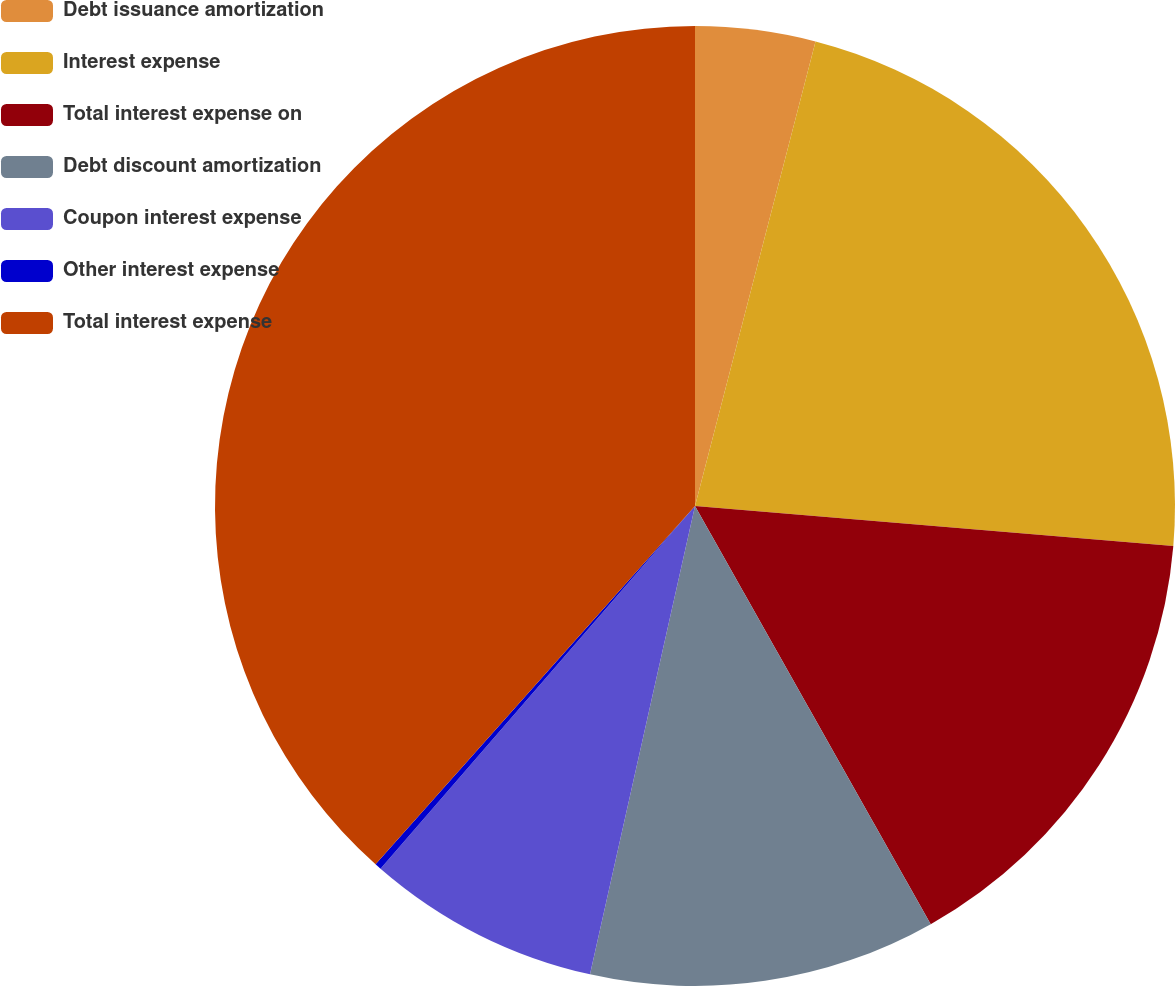Convert chart. <chart><loc_0><loc_0><loc_500><loc_500><pie_chart><fcel>Debt issuance amortization<fcel>Interest expense<fcel>Total interest expense on<fcel>Debt discount amortization<fcel>Coupon interest expense<fcel>Other interest expense<fcel>Total interest expense<nl><fcel>4.04%<fcel>22.29%<fcel>15.5%<fcel>11.68%<fcel>7.86%<fcel>0.22%<fcel>38.41%<nl></chart> 